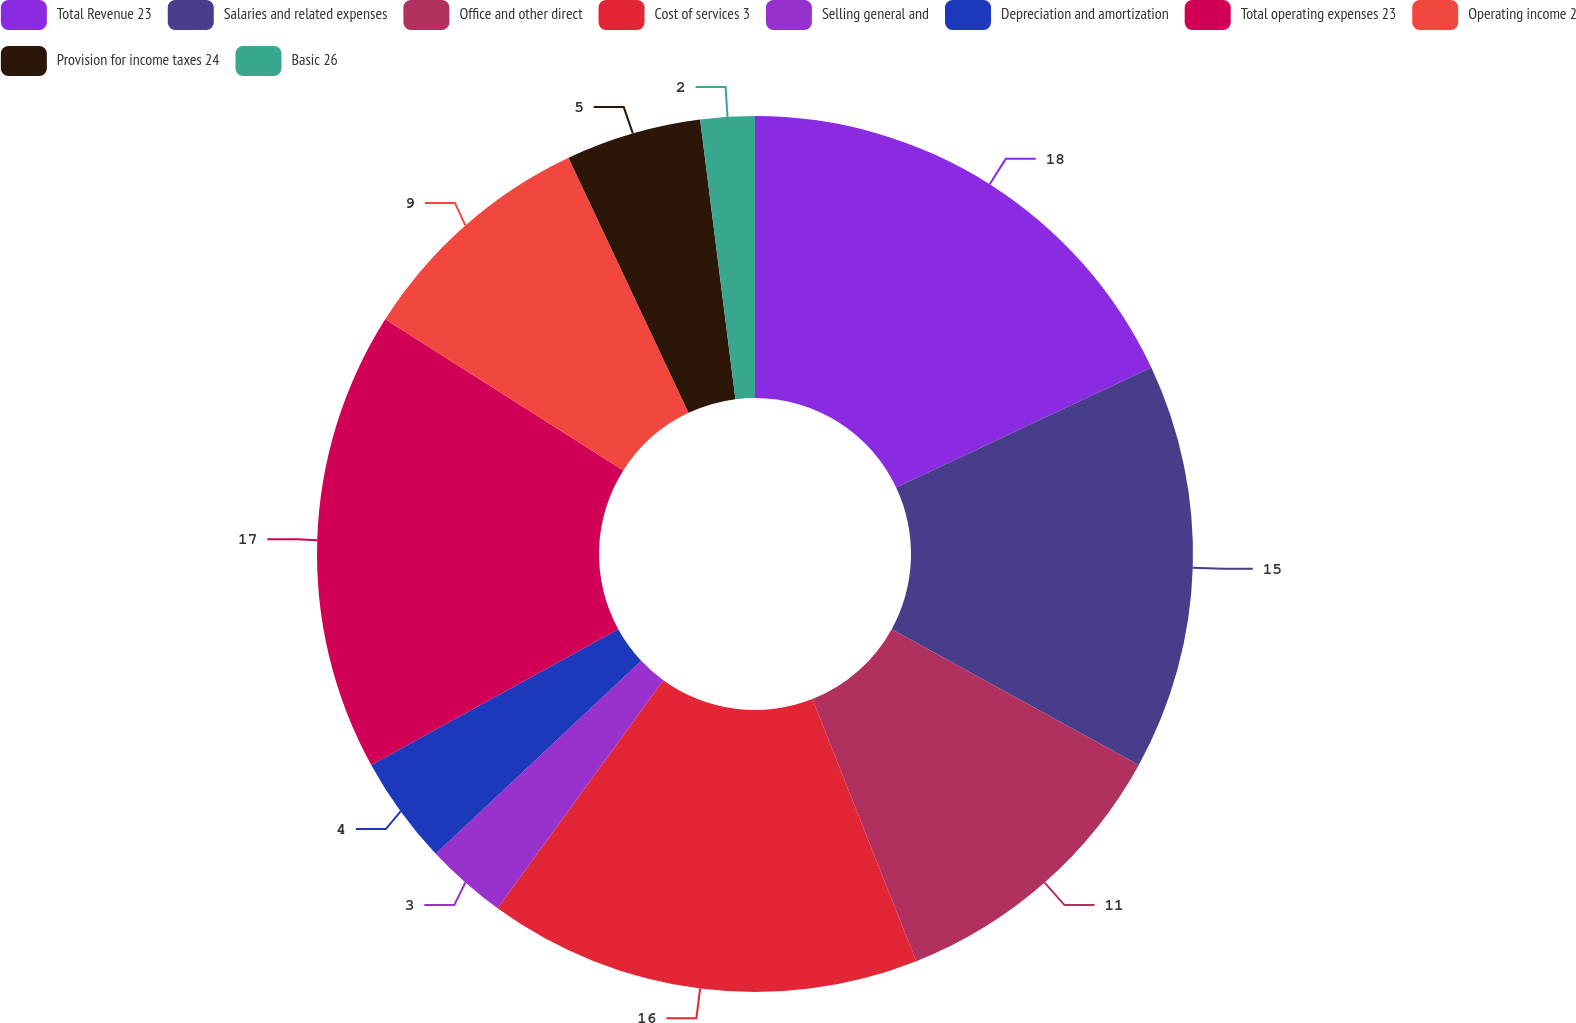Convert chart to OTSL. <chart><loc_0><loc_0><loc_500><loc_500><pie_chart><fcel>Total Revenue 23<fcel>Salaries and related expenses<fcel>Office and other direct<fcel>Cost of services 3<fcel>Selling general and<fcel>Depreciation and amortization<fcel>Total operating expenses 23<fcel>Operating income 2<fcel>Provision for income taxes 24<fcel>Basic 26<nl><fcel>18.0%<fcel>15.0%<fcel>11.0%<fcel>16.0%<fcel>3.0%<fcel>4.0%<fcel>17.0%<fcel>9.0%<fcel>5.0%<fcel>2.0%<nl></chart> 